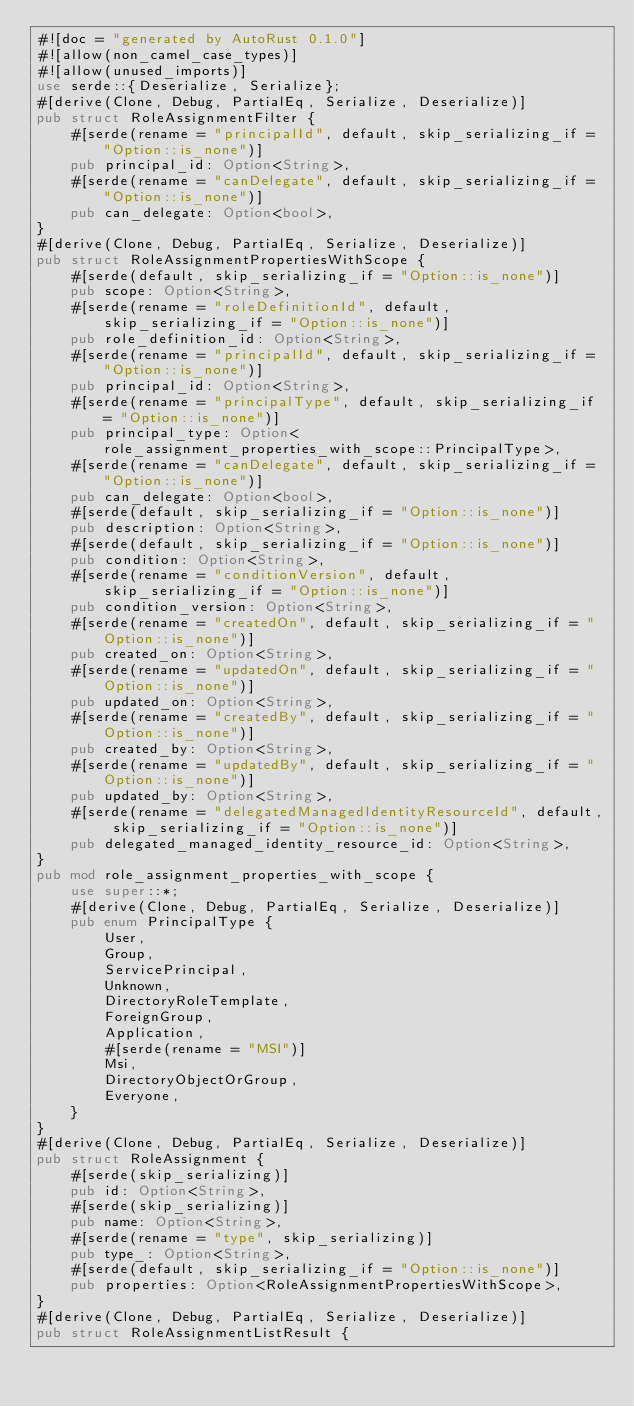<code> <loc_0><loc_0><loc_500><loc_500><_Rust_>#![doc = "generated by AutoRust 0.1.0"]
#![allow(non_camel_case_types)]
#![allow(unused_imports)]
use serde::{Deserialize, Serialize};
#[derive(Clone, Debug, PartialEq, Serialize, Deserialize)]
pub struct RoleAssignmentFilter {
    #[serde(rename = "principalId", default, skip_serializing_if = "Option::is_none")]
    pub principal_id: Option<String>,
    #[serde(rename = "canDelegate", default, skip_serializing_if = "Option::is_none")]
    pub can_delegate: Option<bool>,
}
#[derive(Clone, Debug, PartialEq, Serialize, Deserialize)]
pub struct RoleAssignmentPropertiesWithScope {
    #[serde(default, skip_serializing_if = "Option::is_none")]
    pub scope: Option<String>,
    #[serde(rename = "roleDefinitionId", default, skip_serializing_if = "Option::is_none")]
    pub role_definition_id: Option<String>,
    #[serde(rename = "principalId", default, skip_serializing_if = "Option::is_none")]
    pub principal_id: Option<String>,
    #[serde(rename = "principalType", default, skip_serializing_if = "Option::is_none")]
    pub principal_type: Option<role_assignment_properties_with_scope::PrincipalType>,
    #[serde(rename = "canDelegate", default, skip_serializing_if = "Option::is_none")]
    pub can_delegate: Option<bool>,
    #[serde(default, skip_serializing_if = "Option::is_none")]
    pub description: Option<String>,
    #[serde(default, skip_serializing_if = "Option::is_none")]
    pub condition: Option<String>,
    #[serde(rename = "conditionVersion", default, skip_serializing_if = "Option::is_none")]
    pub condition_version: Option<String>,
    #[serde(rename = "createdOn", default, skip_serializing_if = "Option::is_none")]
    pub created_on: Option<String>,
    #[serde(rename = "updatedOn", default, skip_serializing_if = "Option::is_none")]
    pub updated_on: Option<String>,
    #[serde(rename = "createdBy", default, skip_serializing_if = "Option::is_none")]
    pub created_by: Option<String>,
    #[serde(rename = "updatedBy", default, skip_serializing_if = "Option::is_none")]
    pub updated_by: Option<String>,
    #[serde(rename = "delegatedManagedIdentityResourceId", default, skip_serializing_if = "Option::is_none")]
    pub delegated_managed_identity_resource_id: Option<String>,
}
pub mod role_assignment_properties_with_scope {
    use super::*;
    #[derive(Clone, Debug, PartialEq, Serialize, Deserialize)]
    pub enum PrincipalType {
        User,
        Group,
        ServicePrincipal,
        Unknown,
        DirectoryRoleTemplate,
        ForeignGroup,
        Application,
        #[serde(rename = "MSI")]
        Msi,
        DirectoryObjectOrGroup,
        Everyone,
    }
}
#[derive(Clone, Debug, PartialEq, Serialize, Deserialize)]
pub struct RoleAssignment {
    #[serde(skip_serializing)]
    pub id: Option<String>,
    #[serde(skip_serializing)]
    pub name: Option<String>,
    #[serde(rename = "type", skip_serializing)]
    pub type_: Option<String>,
    #[serde(default, skip_serializing_if = "Option::is_none")]
    pub properties: Option<RoleAssignmentPropertiesWithScope>,
}
#[derive(Clone, Debug, PartialEq, Serialize, Deserialize)]
pub struct RoleAssignmentListResult {</code> 